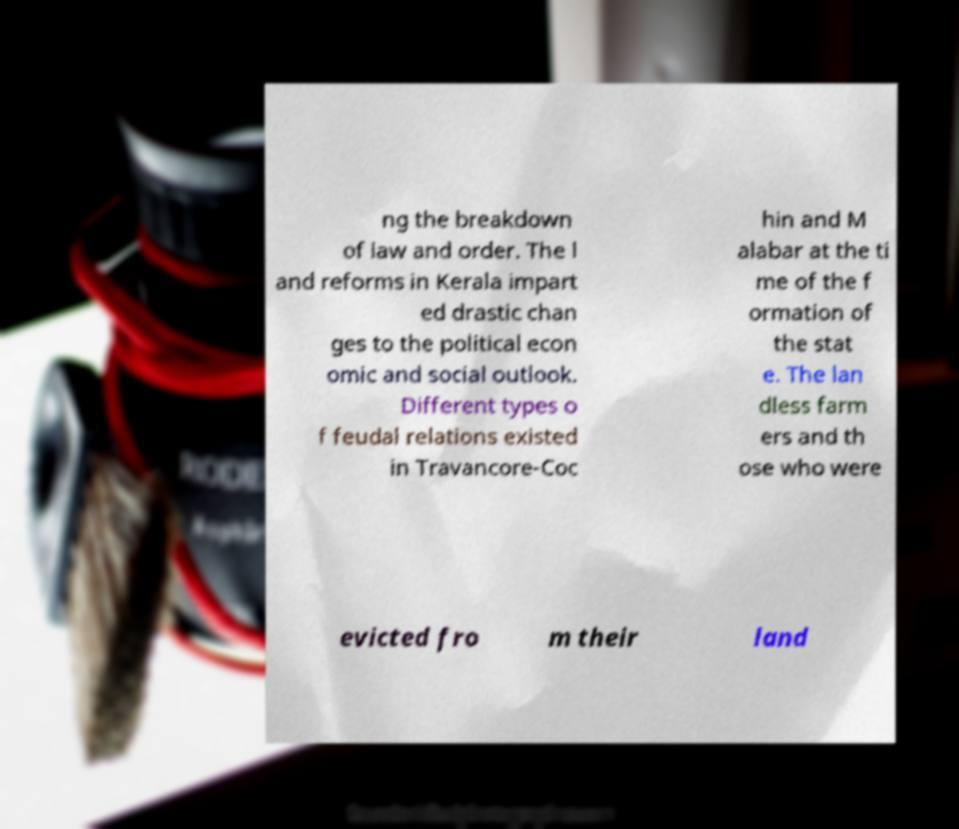Can you accurately transcribe the text from the provided image for me? ng the breakdown of law and order. The l and reforms in Kerala impart ed drastic chan ges to the political econ omic and social outlook. Different types o f feudal relations existed in Travancore-Coc hin and M alabar at the ti me of the f ormation of the stat e. The lan dless farm ers and th ose who were evicted fro m their land 